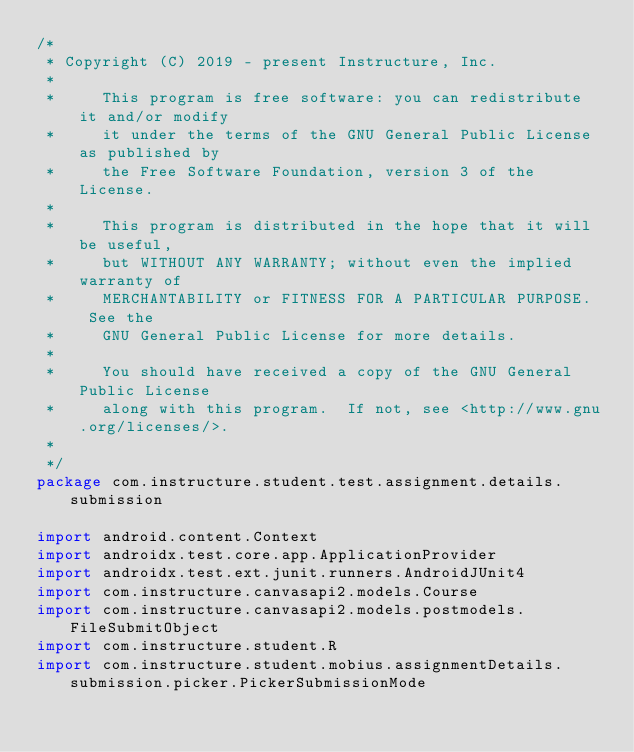<code> <loc_0><loc_0><loc_500><loc_500><_Kotlin_>/*
 * Copyright (C) 2019 - present Instructure, Inc.
 *
 *     This program is free software: you can redistribute it and/or modify
 *     it under the terms of the GNU General Public License as published by
 *     the Free Software Foundation, version 3 of the License.
 *
 *     This program is distributed in the hope that it will be useful,
 *     but WITHOUT ANY WARRANTY; without even the implied warranty of
 *     MERCHANTABILITY or FITNESS FOR A PARTICULAR PURPOSE.  See the
 *     GNU General Public License for more details.
 *
 *     You should have received a copy of the GNU General Public License
 *     along with this program.  If not, see <http://www.gnu.org/licenses/>.
 *
 */
package com.instructure.student.test.assignment.details.submission

import android.content.Context
import androidx.test.core.app.ApplicationProvider
import androidx.test.ext.junit.runners.AndroidJUnit4
import com.instructure.canvasapi2.models.Course
import com.instructure.canvasapi2.models.postmodels.FileSubmitObject
import com.instructure.student.R
import com.instructure.student.mobius.assignmentDetails.submission.picker.PickerSubmissionMode</code> 